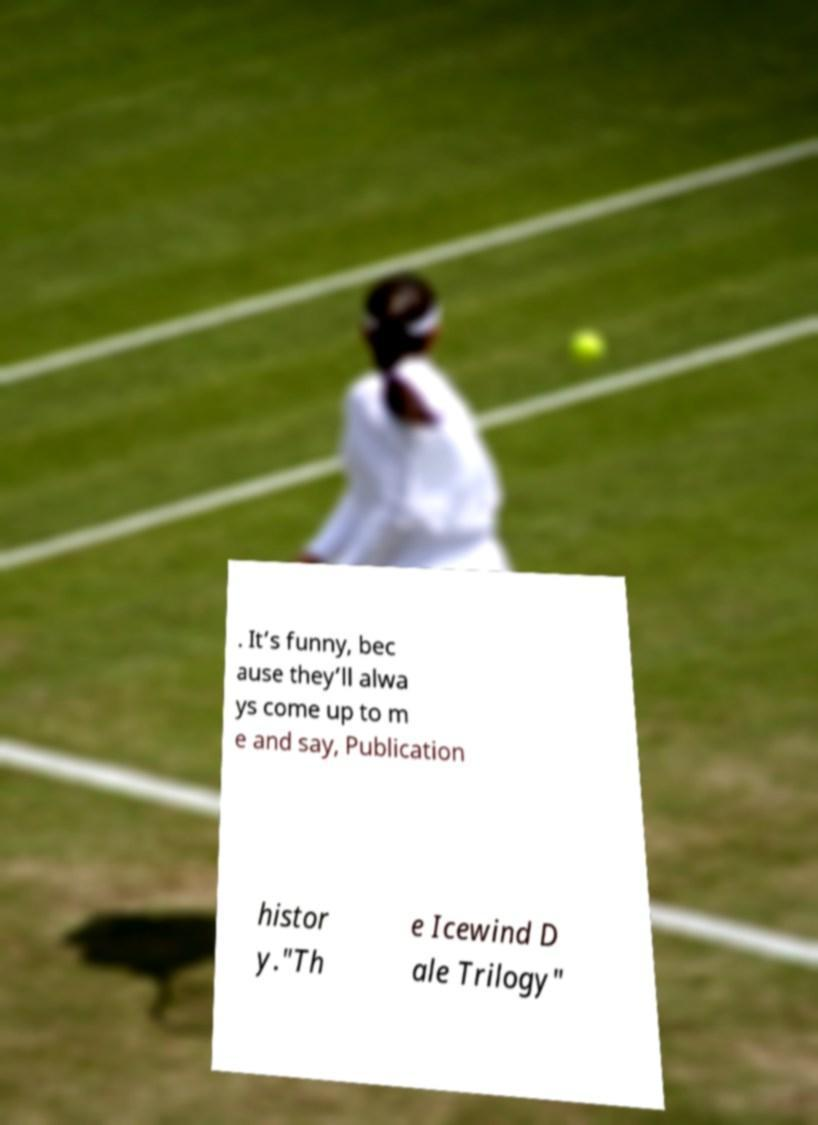What messages or text are displayed in this image? I need them in a readable, typed format. . It’s funny, bec ause they’ll alwa ys come up to m e and say, Publication histor y."Th e Icewind D ale Trilogy" 